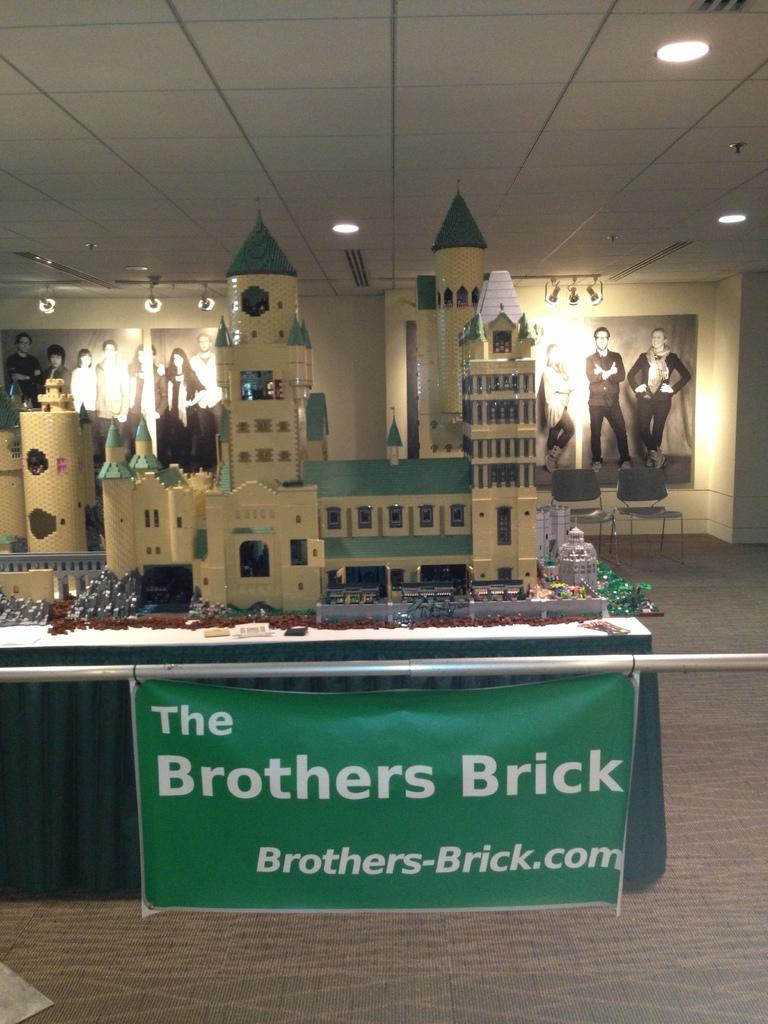<image>
Present a compact description of the photo's key features. A replica of a castle sits behind a sign that says The Brothers Brick. 